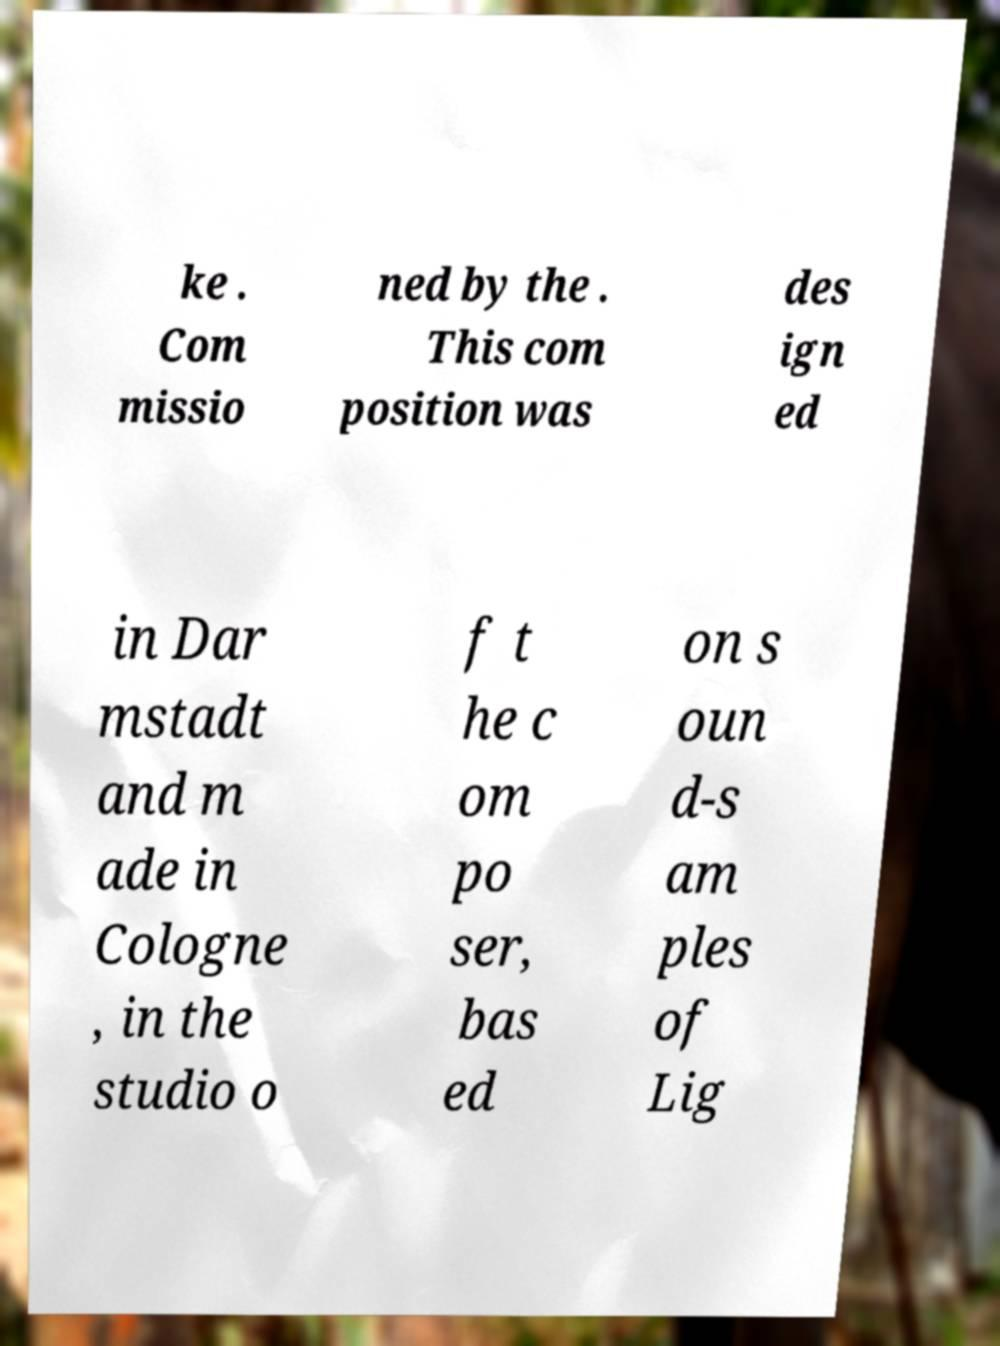Could you extract and type out the text from this image? ke . Com missio ned by the . This com position was des ign ed in Dar mstadt and m ade in Cologne , in the studio o f t he c om po ser, bas ed on s oun d-s am ples of Lig 